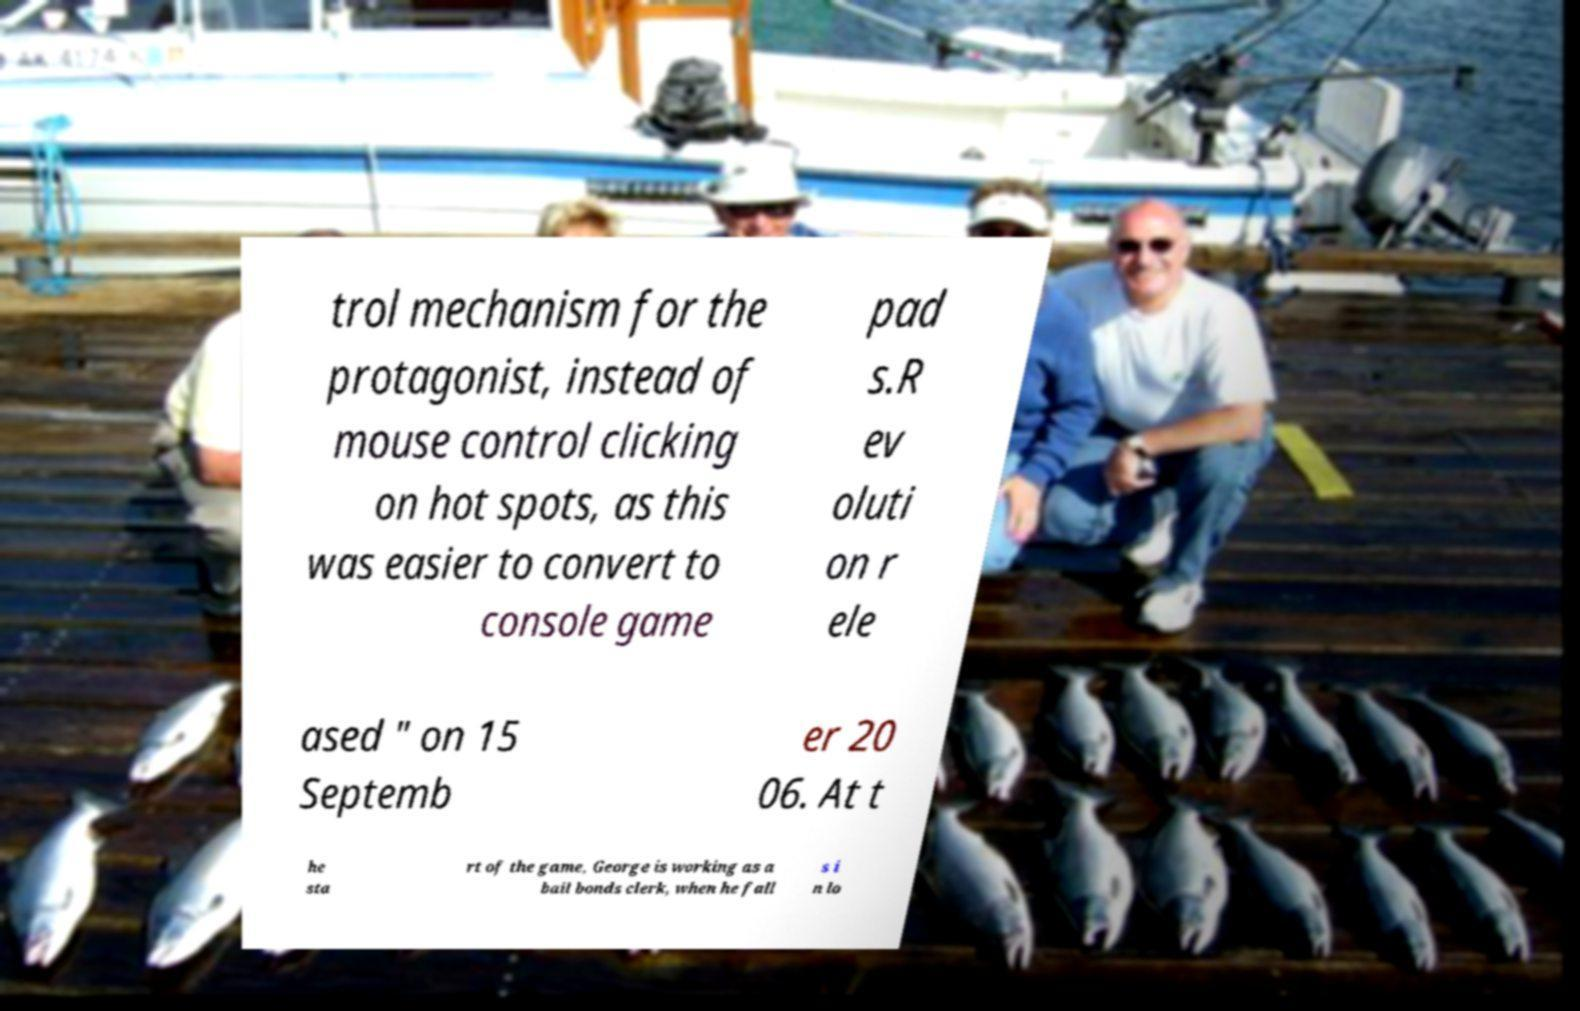I need the written content from this picture converted into text. Can you do that? trol mechanism for the protagonist, instead of mouse control clicking on hot spots, as this was easier to convert to console game pad s.R ev oluti on r ele ased " on 15 Septemb er 20 06. At t he sta rt of the game, George is working as a bail bonds clerk, when he fall s i n lo 